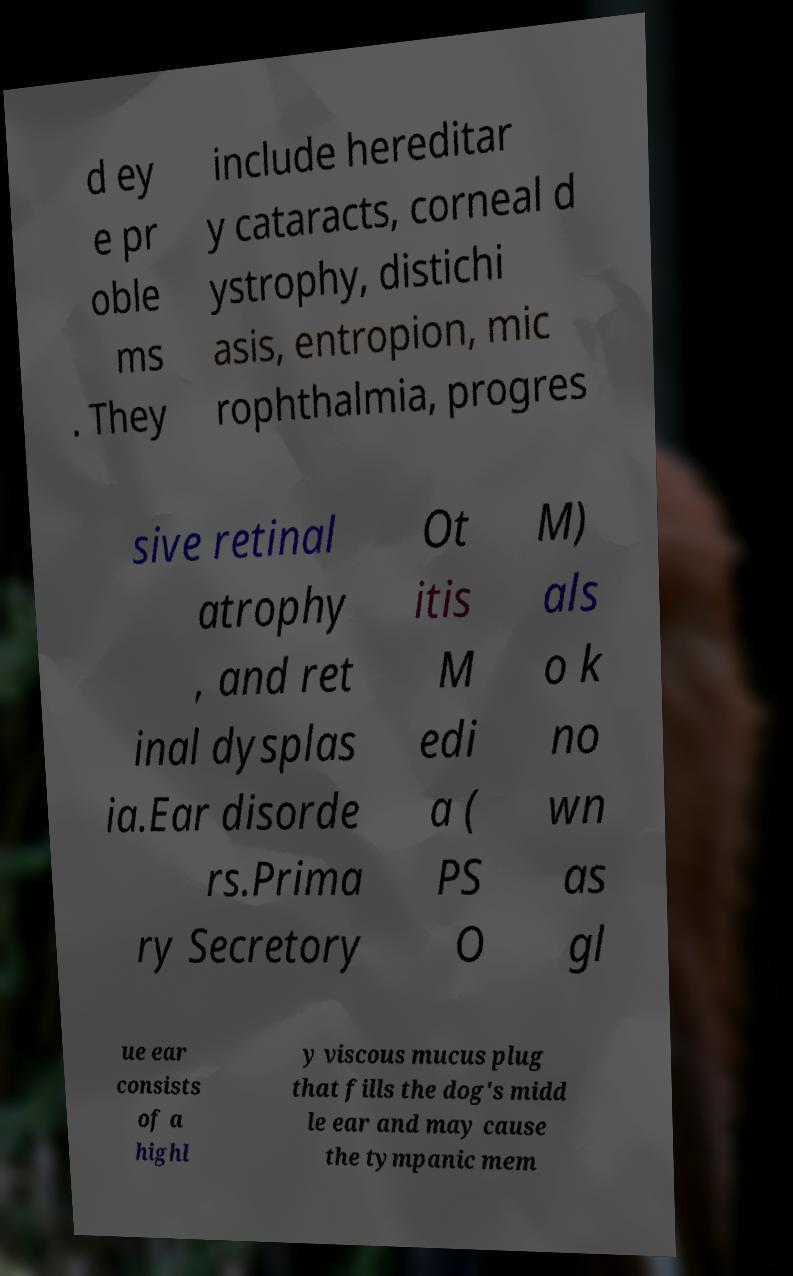Could you extract and type out the text from this image? d ey e pr oble ms . They include hereditar y cataracts, corneal d ystrophy, distichi asis, entropion, mic rophthalmia, progres sive retinal atrophy , and ret inal dysplas ia.Ear disorde rs.Prima ry Secretory Ot itis M edi a ( PS O M) als o k no wn as gl ue ear consists of a highl y viscous mucus plug that fills the dog's midd le ear and may cause the tympanic mem 